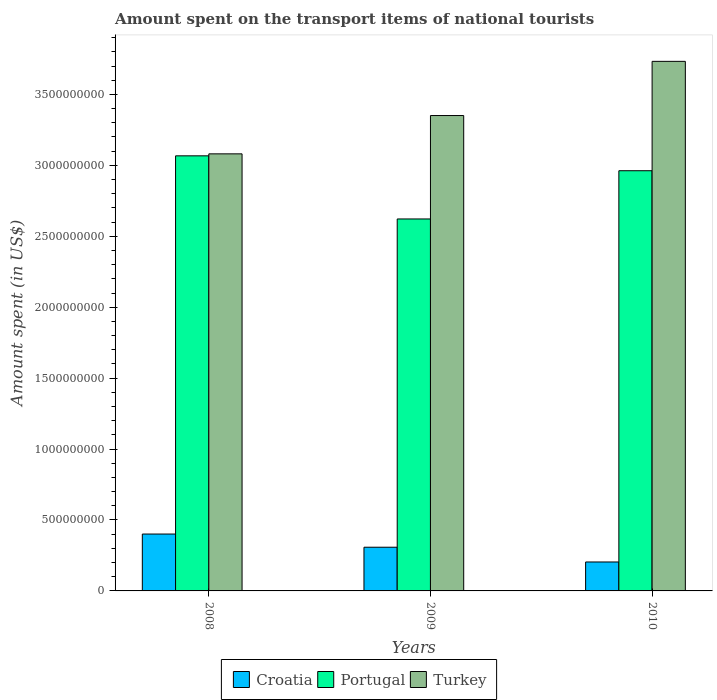How many different coloured bars are there?
Your answer should be very brief. 3. Are the number of bars per tick equal to the number of legend labels?
Your response must be concise. Yes. How many bars are there on the 2nd tick from the left?
Keep it short and to the point. 3. In how many cases, is the number of bars for a given year not equal to the number of legend labels?
Ensure brevity in your answer.  0. What is the amount spent on the transport items of national tourists in Croatia in 2010?
Provide a short and direct response. 2.04e+08. Across all years, what is the maximum amount spent on the transport items of national tourists in Portugal?
Provide a short and direct response. 3.07e+09. Across all years, what is the minimum amount spent on the transport items of national tourists in Croatia?
Your response must be concise. 2.04e+08. In which year was the amount spent on the transport items of national tourists in Croatia minimum?
Provide a short and direct response. 2010. What is the total amount spent on the transport items of national tourists in Portugal in the graph?
Your answer should be compact. 8.65e+09. What is the difference between the amount spent on the transport items of national tourists in Portugal in 2008 and that in 2009?
Provide a succinct answer. 4.45e+08. What is the difference between the amount spent on the transport items of national tourists in Turkey in 2008 and the amount spent on the transport items of national tourists in Croatia in 2009?
Your answer should be very brief. 2.77e+09. What is the average amount spent on the transport items of national tourists in Turkey per year?
Offer a terse response. 3.39e+09. In the year 2010, what is the difference between the amount spent on the transport items of national tourists in Portugal and amount spent on the transport items of national tourists in Croatia?
Your answer should be compact. 2.76e+09. What is the ratio of the amount spent on the transport items of national tourists in Croatia in 2008 to that in 2010?
Your response must be concise. 1.97. Is the amount spent on the transport items of national tourists in Portugal in 2008 less than that in 2009?
Your answer should be very brief. No. What is the difference between the highest and the second highest amount spent on the transport items of national tourists in Turkey?
Provide a succinct answer. 3.82e+08. What is the difference between the highest and the lowest amount spent on the transport items of national tourists in Turkey?
Offer a very short reply. 6.52e+08. Is the sum of the amount spent on the transport items of national tourists in Turkey in 2009 and 2010 greater than the maximum amount spent on the transport items of national tourists in Croatia across all years?
Ensure brevity in your answer.  Yes. What does the 1st bar from the left in 2009 represents?
Offer a very short reply. Croatia. What does the 3rd bar from the right in 2010 represents?
Your answer should be very brief. Croatia. Is it the case that in every year, the sum of the amount spent on the transport items of national tourists in Croatia and amount spent on the transport items of national tourists in Turkey is greater than the amount spent on the transport items of national tourists in Portugal?
Make the answer very short. Yes. Are all the bars in the graph horizontal?
Provide a short and direct response. No. What is the difference between two consecutive major ticks on the Y-axis?
Make the answer very short. 5.00e+08. Are the values on the major ticks of Y-axis written in scientific E-notation?
Offer a very short reply. No. Does the graph contain any zero values?
Your answer should be very brief. No. Does the graph contain grids?
Ensure brevity in your answer.  No. What is the title of the graph?
Offer a terse response. Amount spent on the transport items of national tourists. Does "Kosovo" appear as one of the legend labels in the graph?
Provide a short and direct response. No. What is the label or title of the Y-axis?
Your answer should be very brief. Amount spent (in US$). What is the Amount spent (in US$) in Croatia in 2008?
Your answer should be very brief. 4.01e+08. What is the Amount spent (in US$) of Portugal in 2008?
Your response must be concise. 3.07e+09. What is the Amount spent (in US$) of Turkey in 2008?
Offer a very short reply. 3.08e+09. What is the Amount spent (in US$) of Croatia in 2009?
Your response must be concise. 3.08e+08. What is the Amount spent (in US$) in Portugal in 2009?
Make the answer very short. 2.62e+09. What is the Amount spent (in US$) in Turkey in 2009?
Provide a short and direct response. 3.35e+09. What is the Amount spent (in US$) in Croatia in 2010?
Offer a terse response. 2.04e+08. What is the Amount spent (in US$) of Portugal in 2010?
Your answer should be very brief. 2.96e+09. What is the Amount spent (in US$) in Turkey in 2010?
Your answer should be compact. 3.73e+09. Across all years, what is the maximum Amount spent (in US$) of Croatia?
Offer a terse response. 4.01e+08. Across all years, what is the maximum Amount spent (in US$) of Portugal?
Make the answer very short. 3.07e+09. Across all years, what is the maximum Amount spent (in US$) of Turkey?
Keep it short and to the point. 3.73e+09. Across all years, what is the minimum Amount spent (in US$) in Croatia?
Ensure brevity in your answer.  2.04e+08. Across all years, what is the minimum Amount spent (in US$) in Portugal?
Offer a very short reply. 2.62e+09. Across all years, what is the minimum Amount spent (in US$) in Turkey?
Your answer should be compact. 3.08e+09. What is the total Amount spent (in US$) in Croatia in the graph?
Your response must be concise. 9.13e+08. What is the total Amount spent (in US$) of Portugal in the graph?
Provide a short and direct response. 8.65e+09. What is the total Amount spent (in US$) of Turkey in the graph?
Keep it short and to the point. 1.02e+1. What is the difference between the Amount spent (in US$) of Croatia in 2008 and that in 2009?
Ensure brevity in your answer.  9.30e+07. What is the difference between the Amount spent (in US$) of Portugal in 2008 and that in 2009?
Your answer should be compact. 4.45e+08. What is the difference between the Amount spent (in US$) of Turkey in 2008 and that in 2009?
Provide a short and direct response. -2.70e+08. What is the difference between the Amount spent (in US$) in Croatia in 2008 and that in 2010?
Offer a very short reply. 1.97e+08. What is the difference between the Amount spent (in US$) in Portugal in 2008 and that in 2010?
Offer a very short reply. 1.05e+08. What is the difference between the Amount spent (in US$) of Turkey in 2008 and that in 2010?
Your response must be concise. -6.52e+08. What is the difference between the Amount spent (in US$) of Croatia in 2009 and that in 2010?
Give a very brief answer. 1.04e+08. What is the difference between the Amount spent (in US$) of Portugal in 2009 and that in 2010?
Your answer should be very brief. -3.40e+08. What is the difference between the Amount spent (in US$) in Turkey in 2009 and that in 2010?
Give a very brief answer. -3.82e+08. What is the difference between the Amount spent (in US$) in Croatia in 2008 and the Amount spent (in US$) in Portugal in 2009?
Make the answer very short. -2.22e+09. What is the difference between the Amount spent (in US$) of Croatia in 2008 and the Amount spent (in US$) of Turkey in 2009?
Offer a terse response. -2.95e+09. What is the difference between the Amount spent (in US$) in Portugal in 2008 and the Amount spent (in US$) in Turkey in 2009?
Ensure brevity in your answer.  -2.84e+08. What is the difference between the Amount spent (in US$) in Croatia in 2008 and the Amount spent (in US$) in Portugal in 2010?
Keep it short and to the point. -2.56e+09. What is the difference between the Amount spent (in US$) of Croatia in 2008 and the Amount spent (in US$) of Turkey in 2010?
Give a very brief answer. -3.33e+09. What is the difference between the Amount spent (in US$) of Portugal in 2008 and the Amount spent (in US$) of Turkey in 2010?
Make the answer very short. -6.66e+08. What is the difference between the Amount spent (in US$) in Croatia in 2009 and the Amount spent (in US$) in Portugal in 2010?
Your answer should be very brief. -2.65e+09. What is the difference between the Amount spent (in US$) of Croatia in 2009 and the Amount spent (in US$) of Turkey in 2010?
Keep it short and to the point. -3.42e+09. What is the difference between the Amount spent (in US$) in Portugal in 2009 and the Amount spent (in US$) in Turkey in 2010?
Your response must be concise. -1.11e+09. What is the average Amount spent (in US$) in Croatia per year?
Your answer should be compact. 3.04e+08. What is the average Amount spent (in US$) in Portugal per year?
Give a very brief answer. 2.88e+09. What is the average Amount spent (in US$) in Turkey per year?
Your answer should be very brief. 3.39e+09. In the year 2008, what is the difference between the Amount spent (in US$) in Croatia and Amount spent (in US$) in Portugal?
Offer a very short reply. -2.67e+09. In the year 2008, what is the difference between the Amount spent (in US$) of Croatia and Amount spent (in US$) of Turkey?
Your response must be concise. -2.68e+09. In the year 2008, what is the difference between the Amount spent (in US$) in Portugal and Amount spent (in US$) in Turkey?
Provide a short and direct response. -1.40e+07. In the year 2009, what is the difference between the Amount spent (in US$) in Croatia and Amount spent (in US$) in Portugal?
Give a very brief answer. -2.31e+09. In the year 2009, what is the difference between the Amount spent (in US$) in Croatia and Amount spent (in US$) in Turkey?
Ensure brevity in your answer.  -3.04e+09. In the year 2009, what is the difference between the Amount spent (in US$) of Portugal and Amount spent (in US$) of Turkey?
Make the answer very short. -7.29e+08. In the year 2010, what is the difference between the Amount spent (in US$) of Croatia and Amount spent (in US$) of Portugal?
Offer a very short reply. -2.76e+09. In the year 2010, what is the difference between the Amount spent (in US$) in Croatia and Amount spent (in US$) in Turkey?
Your response must be concise. -3.53e+09. In the year 2010, what is the difference between the Amount spent (in US$) in Portugal and Amount spent (in US$) in Turkey?
Offer a terse response. -7.71e+08. What is the ratio of the Amount spent (in US$) in Croatia in 2008 to that in 2009?
Your answer should be very brief. 1.3. What is the ratio of the Amount spent (in US$) of Portugal in 2008 to that in 2009?
Your response must be concise. 1.17. What is the ratio of the Amount spent (in US$) in Turkey in 2008 to that in 2009?
Your answer should be compact. 0.92. What is the ratio of the Amount spent (in US$) in Croatia in 2008 to that in 2010?
Your answer should be very brief. 1.97. What is the ratio of the Amount spent (in US$) in Portugal in 2008 to that in 2010?
Provide a short and direct response. 1.04. What is the ratio of the Amount spent (in US$) of Turkey in 2008 to that in 2010?
Keep it short and to the point. 0.83. What is the ratio of the Amount spent (in US$) in Croatia in 2009 to that in 2010?
Provide a short and direct response. 1.51. What is the ratio of the Amount spent (in US$) of Portugal in 2009 to that in 2010?
Keep it short and to the point. 0.89. What is the ratio of the Amount spent (in US$) in Turkey in 2009 to that in 2010?
Make the answer very short. 0.9. What is the difference between the highest and the second highest Amount spent (in US$) in Croatia?
Offer a very short reply. 9.30e+07. What is the difference between the highest and the second highest Amount spent (in US$) of Portugal?
Keep it short and to the point. 1.05e+08. What is the difference between the highest and the second highest Amount spent (in US$) of Turkey?
Offer a terse response. 3.82e+08. What is the difference between the highest and the lowest Amount spent (in US$) in Croatia?
Your response must be concise. 1.97e+08. What is the difference between the highest and the lowest Amount spent (in US$) of Portugal?
Make the answer very short. 4.45e+08. What is the difference between the highest and the lowest Amount spent (in US$) of Turkey?
Offer a terse response. 6.52e+08. 